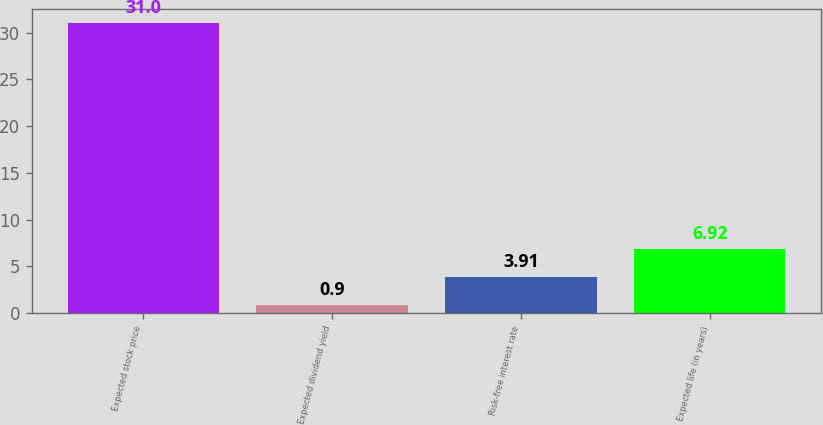Convert chart to OTSL. <chart><loc_0><loc_0><loc_500><loc_500><bar_chart><fcel>Expected stock price<fcel>Expected dividend yield<fcel>Risk-free interest rate<fcel>Expected life (in years)<nl><fcel>31<fcel>0.9<fcel>3.91<fcel>6.92<nl></chart> 